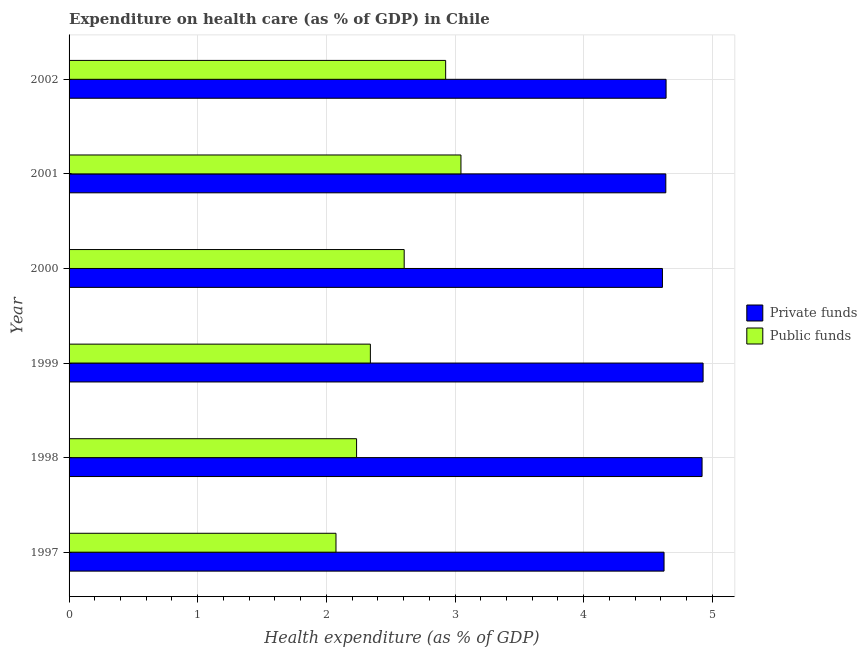How many different coloured bars are there?
Keep it short and to the point. 2. How many groups of bars are there?
Your answer should be compact. 6. Are the number of bars per tick equal to the number of legend labels?
Give a very brief answer. Yes. Are the number of bars on each tick of the Y-axis equal?
Offer a very short reply. Yes. How many bars are there on the 2nd tick from the top?
Ensure brevity in your answer.  2. In how many cases, is the number of bars for a given year not equal to the number of legend labels?
Your response must be concise. 0. What is the amount of private funds spent in healthcare in 2002?
Provide a short and direct response. 4.64. Across all years, what is the maximum amount of public funds spent in healthcare?
Provide a short and direct response. 3.05. Across all years, what is the minimum amount of private funds spent in healthcare?
Your answer should be compact. 4.61. What is the total amount of private funds spent in healthcare in the graph?
Keep it short and to the point. 28.37. What is the difference between the amount of public funds spent in healthcare in 1997 and that in 1999?
Provide a succinct answer. -0.27. What is the difference between the amount of public funds spent in healthcare in 2002 and the amount of private funds spent in healthcare in 2000?
Provide a short and direct response. -1.69. What is the average amount of private funds spent in healthcare per year?
Ensure brevity in your answer.  4.73. In the year 2000, what is the difference between the amount of private funds spent in healthcare and amount of public funds spent in healthcare?
Offer a terse response. 2.01. What is the ratio of the amount of private funds spent in healthcare in 2000 to that in 2001?
Provide a short and direct response. 0.99. Is the difference between the amount of private funds spent in healthcare in 1998 and 2001 greater than the difference between the amount of public funds spent in healthcare in 1998 and 2001?
Make the answer very short. Yes. What is the difference between the highest and the second highest amount of private funds spent in healthcare?
Ensure brevity in your answer.  0.01. What is the difference between the highest and the lowest amount of private funds spent in healthcare?
Make the answer very short. 0.32. In how many years, is the amount of public funds spent in healthcare greater than the average amount of public funds spent in healthcare taken over all years?
Your answer should be compact. 3. Is the sum of the amount of public funds spent in healthcare in 1999 and 2002 greater than the maximum amount of private funds spent in healthcare across all years?
Keep it short and to the point. Yes. What does the 2nd bar from the top in 2000 represents?
Your response must be concise. Private funds. What does the 1st bar from the bottom in 2000 represents?
Give a very brief answer. Private funds. Are all the bars in the graph horizontal?
Provide a short and direct response. Yes. Does the graph contain any zero values?
Ensure brevity in your answer.  No. Does the graph contain grids?
Your answer should be very brief. Yes. How many legend labels are there?
Offer a very short reply. 2. What is the title of the graph?
Make the answer very short. Expenditure on health care (as % of GDP) in Chile. Does "Old" appear as one of the legend labels in the graph?
Your response must be concise. No. What is the label or title of the X-axis?
Your answer should be compact. Health expenditure (as % of GDP). What is the Health expenditure (as % of GDP) of Private funds in 1997?
Ensure brevity in your answer.  4.62. What is the Health expenditure (as % of GDP) in Public funds in 1997?
Ensure brevity in your answer.  2.07. What is the Health expenditure (as % of GDP) of Private funds in 1998?
Give a very brief answer. 4.92. What is the Health expenditure (as % of GDP) in Public funds in 1998?
Give a very brief answer. 2.23. What is the Health expenditure (as % of GDP) in Private funds in 1999?
Your answer should be compact. 4.93. What is the Health expenditure (as % of GDP) of Public funds in 1999?
Ensure brevity in your answer.  2.34. What is the Health expenditure (as % of GDP) of Private funds in 2000?
Ensure brevity in your answer.  4.61. What is the Health expenditure (as % of GDP) in Public funds in 2000?
Offer a very short reply. 2.6. What is the Health expenditure (as % of GDP) of Private funds in 2001?
Ensure brevity in your answer.  4.64. What is the Health expenditure (as % of GDP) of Public funds in 2001?
Your answer should be compact. 3.05. What is the Health expenditure (as % of GDP) in Private funds in 2002?
Provide a short and direct response. 4.64. What is the Health expenditure (as % of GDP) of Public funds in 2002?
Offer a very short reply. 2.93. Across all years, what is the maximum Health expenditure (as % of GDP) in Private funds?
Offer a terse response. 4.93. Across all years, what is the maximum Health expenditure (as % of GDP) of Public funds?
Offer a very short reply. 3.05. Across all years, what is the minimum Health expenditure (as % of GDP) of Private funds?
Give a very brief answer. 4.61. Across all years, what is the minimum Health expenditure (as % of GDP) in Public funds?
Your answer should be very brief. 2.07. What is the total Health expenditure (as % of GDP) in Private funds in the graph?
Give a very brief answer. 28.37. What is the total Health expenditure (as % of GDP) of Public funds in the graph?
Your response must be concise. 15.23. What is the difference between the Health expenditure (as % of GDP) in Private funds in 1997 and that in 1998?
Provide a short and direct response. -0.3. What is the difference between the Health expenditure (as % of GDP) in Public funds in 1997 and that in 1998?
Provide a succinct answer. -0.16. What is the difference between the Health expenditure (as % of GDP) of Private funds in 1997 and that in 1999?
Offer a terse response. -0.3. What is the difference between the Health expenditure (as % of GDP) in Public funds in 1997 and that in 1999?
Your answer should be compact. -0.27. What is the difference between the Health expenditure (as % of GDP) of Private funds in 1997 and that in 2000?
Your answer should be compact. 0.01. What is the difference between the Health expenditure (as % of GDP) of Public funds in 1997 and that in 2000?
Provide a succinct answer. -0.53. What is the difference between the Health expenditure (as % of GDP) in Private funds in 1997 and that in 2001?
Provide a short and direct response. -0.01. What is the difference between the Health expenditure (as % of GDP) of Public funds in 1997 and that in 2001?
Your answer should be very brief. -0.97. What is the difference between the Health expenditure (as % of GDP) of Private funds in 1997 and that in 2002?
Ensure brevity in your answer.  -0.02. What is the difference between the Health expenditure (as % of GDP) of Public funds in 1997 and that in 2002?
Your response must be concise. -0.85. What is the difference between the Health expenditure (as % of GDP) in Private funds in 1998 and that in 1999?
Your answer should be very brief. -0.01. What is the difference between the Health expenditure (as % of GDP) in Public funds in 1998 and that in 1999?
Keep it short and to the point. -0.11. What is the difference between the Health expenditure (as % of GDP) of Private funds in 1998 and that in 2000?
Keep it short and to the point. 0.31. What is the difference between the Health expenditure (as % of GDP) in Public funds in 1998 and that in 2000?
Your response must be concise. -0.37. What is the difference between the Health expenditure (as % of GDP) of Private funds in 1998 and that in 2001?
Make the answer very short. 0.28. What is the difference between the Health expenditure (as % of GDP) of Public funds in 1998 and that in 2001?
Keep it short and to the point. -0.81. What is the difference between the Health expenditure (as % of GDP) of Private funds in 1998 and that in 2002?
Ensure brevity in your answer.  0.28. What is the difference between the Health expenditure (as % of GDP) of Public funds in 1998 and that in 2002?
Ensure brevity in your answer.  -0.69. What is the difference between the Health expenditure (as % of GDP) of Private funds in 1999 and that in 2000?
Provide a succinct answer. 0.32. What is the difference between the Health expenditure (as % of GDP) of Public funds in 1999 and that in 2000?
Your answer should be very brief. -0.26. What is the difference between the Health expenditure (as % of GDP) in Private funds in 1999 and that in 2001?
Provide a short and direct response. 0.29. What is the difference between the Health expenditure (as % of GDP) in Public funds in 1999 and that in 2001?
Offer a terse response. -0.7. What is the difference between the Health expenditure (as % of GDP) of Private funds in 1999 and that in 2002?
Give a very brief answer. 0.29. What is the difference between the Health expenditure (as % of GDP) of Public funds in 1999 and that in 2002?
Ensure brevity in your answer.  -0.59. What is the difference between the Health expenditure (as % of GDP) of Private funds in 2000 and that in 2001?
Make the answer very short. -0.03. What is the difference between the Health expenditure (as % of GDP) in Public funds in 2000 and that in 2001?
Give a very brief answer. -0.44. What is the difference between the Health expenditure (as % of GDP) of Private funds in 2000 and that in 2002?
Offer a terse response. -0.03. What is the difference between the Health expenditure (as % of GDP) in Public funds in 2000 and that in 2002?
Provide a succinct answer. -0.32. What is the difference between the Health expenditure (as % of GDP) in Private funds in 2001 and that in 2002?
Ensure brevity in your answer.  -0. What is the difference between the Health expenditure (as % of GDP) of Public funds in 2001 and that in 2002?
Your response must be concise. 0.12. What is the difference between the Health expenditure (as % of GDP) in Private funds in 1997 and the Health expenditure (as % of GDP) in Public funds in 1998?
Keep it short and to the point. 2.39. What is the difference between the Health expenditure (as % of GDP) of Private funds in 1997 and the Health expenditure (as % of GDP) of Public funds in 1999?
Provide a succinct answer. 2.28. What is the difference between the Health expenditure (as % of GDP) in Private funds in 1997 and the Health expenditure (as % of GDP) in Public funds in 2000?
Offer a terse response. 2.02. What is the difference between the Health expenditure (as % of GDP) in Private funds in 1997 and the Health expenditure (as % of GDP) in Public funds in 2001?
Make the answer very short. 1.58. What is the difference between the Health expenditure (as % of GDP) of Private funds in 1997 and the Health expenditure (as % of GDP) of Public funds in 2002?
Make the answer very short. 1.7. What is the difference between the Health expenditure (as % of GDP) of Private funds in 1998 and the Health expenditure (as % of GDP) of Public funds in 1999?
Keep it short and to the point. 2.58. What is the difference between the Health expenditure (as % of GDP) of Private funds in 1998 and the Health expenditure (as % of GDP) of Public funds in 2000?
Provide a short and direct response. 2.32. What is the difference between the Health expenditure (as % of GDP) of Private funds in 1998 and the Health expenditure (as % of GDP) of Public funds in 2001?
Your response must be concise. 1.87. What is the difference between the Health expenditure (as % of GDP) in Private funds in 1998 and the Health expenditure (as % of GDP) in Public funds in 2002?
Offer a terse response. 1.99. What is the difference between the Health expenditure (as % of GDP) of Private funds in 1999 and the Health expenditure (as % of GDP) of Public funds in 2000?
Make the answer very short. 2.32. What is the difference between the Health expenditure (as % of GDP) of Private funds in 1999 and the Health expenditure (as % of GDP) of Public funds in 2001?
Your answer should be very brief. 1.88. What is the difference between the Health expenditure (as % of GDP) in Private funds in 1999 and the Health expenditure (as % of GDP) in Public funds in 2002?
Provide a succinct answer. 2. What is the difference between the Health expenditure (as % of GDP) of Private funds in 2000 and the Health expenditure (as % of GDP) of Public funds in 2001?
Make the answer very short. 1.57. What is the difference between the Health expenditure (as % of GDP) in Private funds in 2000 and the Health expenditure (as % of GDP) in Public funds in 2002?
Give a very brief answer. 1.69. What is the difference between the Health expenditure (as % of GDP) of Private funds in 2001 and the Health expenditure (as % of GDP) of Public funds in 2002?
Ensure brevity in your answer.  1.71. What is the average Health expenditure (as % of GDP) in Private funds per year?
Offer a very short reply. 4.73. What is the average Health expenditure (as % of GDP) in Public funds per year?
Ensure brevity in your answer.  2.54. In the year 1997, what is the difference between the Health expenditure (as % of GDP) of Private funds and Health expenditure (as % of GDP) of Public funds?
Your answer should be very brief. 2.55. In the year 1998, what is the difference between the Health expenditure (as % of GDP) of Private funds and Health expenditure (as % of GDP) of Public funds?
Keep it short and to the point. 2.69. In the year 1999, what is the difference between the Health expenditure (as % of GDP) of Private funds and Health expenditure (as % of GDP) of Public funds?
Your answer should be very brief. 2.59. In the year 2000, what is the difference between the Health expenditure (as % of GDP) of Private funds and Health expenditure (as % of GDP) of Public funds?
Your response must be concise. 2.01. In the year 2001, what is the difference between the Health expenditure (as % of GDP) in Private funds and Health expenditure (as % of GDP) in Public funds?
Ensure brevity in your answer.  1.59. In the year 2002, what is the difference between the Health expenditure (as % of GDP) in Private funds and Health expenditure (as % of GDP) in Public funds?
Your response must be concise. 1.71. What is the ratio of the Health expenditure (as % of GDP) in Private funds in 1997 to that in 1998?
Provide a succinct answer. 0.94. What is the ratio of the Health expenditure (as % of GDP) in Public funds in 1997 to that in 1998?
Provide a succinct answer. 0.93. What is the ratio of the Health expenditure (as % of GDP) of Private funds in 1997 to that in 1999?
Ensure brevity in your answer.  0.94. What is the ratio of the Health expenditure (as % of GDP) of Public funds in 1997 to that in 1999?
Make the answer very short. 0.89. What is the ratio of the Health expenditure (as % of GDP) of Private funds in 1997 to that in 2000?
Your answer should be compact. 1. What is the ratio of the Health expenditure (as % of GDP) of Public funds in 1997 to that in 2000?
Offer a terse response. 0.8. What is the ratio of the Health expenditure (as % of GDP) in Private funds in 1997 to that in 2001?
Offer a terse response. 1. What is the ratio of the Health expenditure (as % of GDP) in Public funds in 1997 to that in 2001?
Offer a very short reply. 0.68. What is the ratio of the Health expenditure (as % of GDP) in Private funds in 1997 to that in 2002?
Your answer should be compact. 1. What is the ratio of the Health expenditure (as % of GDP) in Public funds in 1997 to that in 2002?
Make the answer very short. 0.71. What is the ratio of the Health expenditure (as % of GDP) in Public funds in 1998 to that in 1999?
Your response must be concise. 0.95. What is the ratio of the Health expenditure (as % of GDP) of Private funds in 1998 to that in 2000?
Provide a short and direct response. 1.07. What is the ratio of the Health expenditure (as % of GDP) in Public funds in 1998 to that in 2000?
Make the answer very short. 0.86. What is the ratio of the Health expenditure (as % of GDP) in Private funds in 1998 to that in 2001?
Give a very brief answer. 1.06. What is the ratio of the Health expenditure (as % of GDP) of Public funds in 1998 to that in 2001?
Your answer should be very brief. 0.73. What is the ratio of the Health expenditure (as % of GDP) of Private funds in 1998 to that in 2002?
Give a very brief answer. 1.06. What is the ratio of the Health expenditure (as % of GDP) in Public funds in 1998 to that in 2002?
Your response must be concise. 0.76. What is the ratio of the Health expenditure (as % of GDP) of Private funds in 1999 to that in 2000?
Give a very brief answer. 1.07. What is the ratio of the Health expenditure (as % of GDP) of Public funds in 1999 to that in 2000?
Offer a very short reply. 0.9. What is the ratio of the Health expenditure (as % of GDP) of Public funds in 1999 to that in 2001?
Your answer should be very brief. 0.77. What is the ratio of the Health expenditure (as % of GDP) in Private funds in 1999 to that in 2002?
Your response must be concise. 1.06. What is the ratio of the Health expenditure (as % of GDP) of Public funds in 1999 to that in 2002?
Your answer should be very brief. 0.8. What is the ratio of the Health expenditure (as % of GDP) of Private funds in 2000 to that in 2001?
Your answer should be compact. 0.99. What is the ratio of the Health expenditure (as % of GDP) in Public funds in 2000 to that in 2001?
Offer a terse response. 0.86. What is the ratio of the Health expenditure (as % of GDP) of Public funds in 2000 to that in 2002?
Offer a very short reply. 0.89. What is the ratio of the Health expenditure (as % of GDP) in Private funds in 2001 to that in 2002?
Give a very brief answer. 1. What is the ratio of the Health expenditure (as % of GDP) of Public funds in 2001 to that in 2002?
Make the answer very short. 1.04. What is the difference between the highest and the second highest Health expenditure (as % of GDP) in Private funds?
Make the answer very short. 0.01. What is the difference between the highest and the second highest Health expenditure (as % of GDP) of Public funds?
Ensure brevity in your answer.  0.12. What is the difference between the highest and the lowest Health expenditure (as % of GDP) in Private funds?
Ensure brevity in your answer.  0.32. What is the difference between the highest and the lowest Health expenditure (as % of GDP) in Public funds?
Your response must be concise. 0.97. 